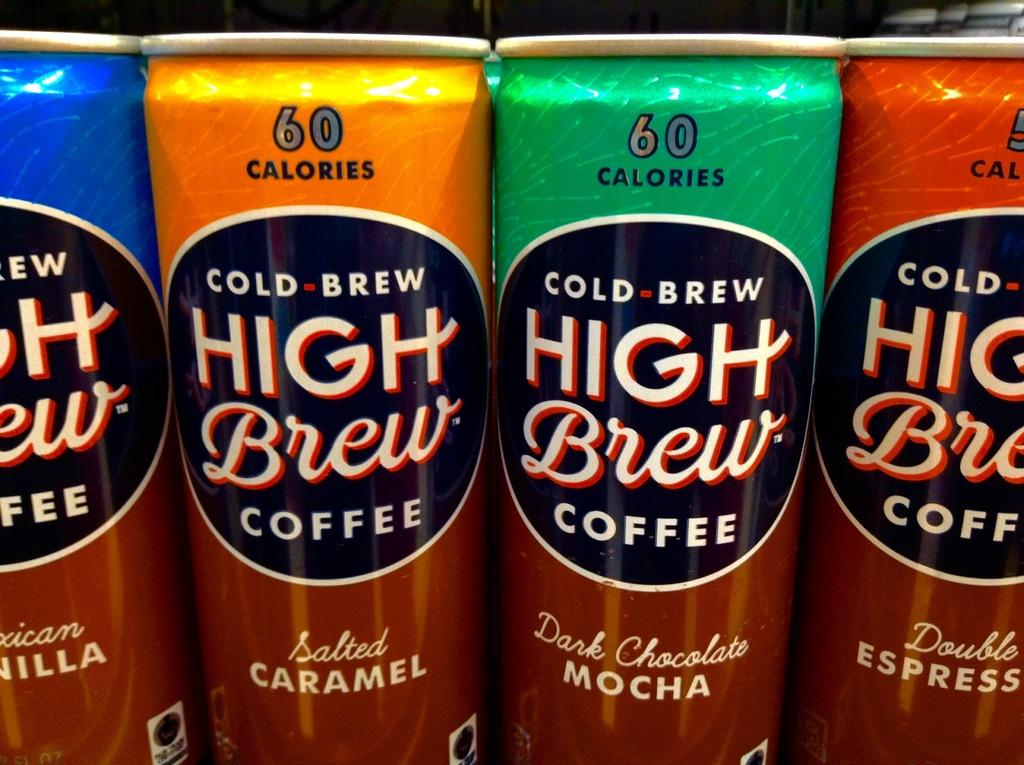<image>
Give a short and clear explanation of the subsequent image. Several cans of High Brew coffee sit next to each other. 